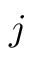Convert formula to latex. <formula><loc_0><loc_0><loc_500><loc_500>j</formula> 